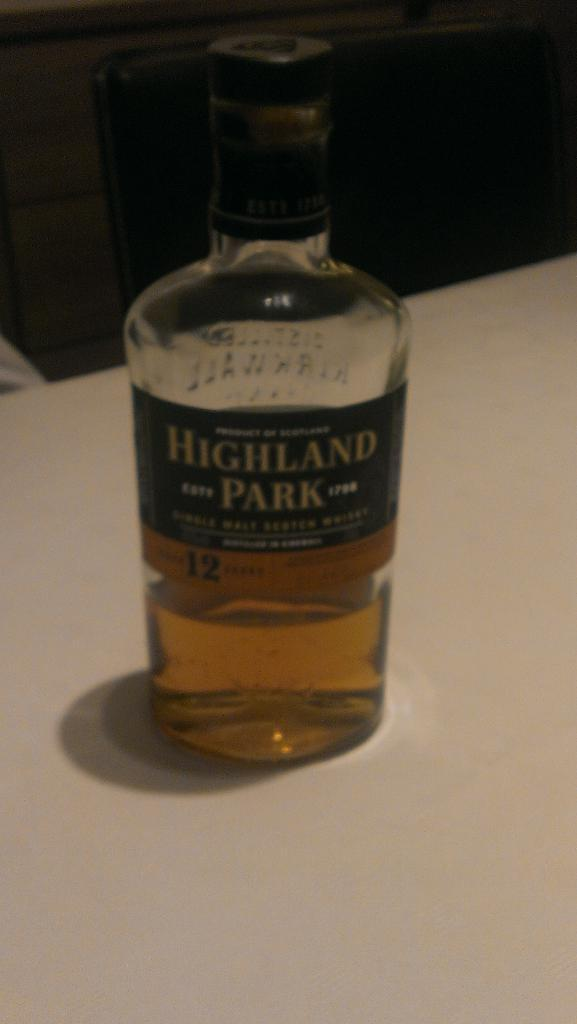<image>
Create a compact narrative representing the image presented. A bottle of alcohol is labeled with the name Highland Park. 